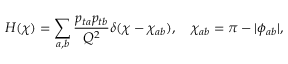Convert formula to latex. <formula><loc_0><loc_0><loc_500><loc_500>H ( \chi ) = \sum _ { a , b } \frac { p _ { t a } p _ { t b } } { Q ^ { 2 } } \delta ( \chi - \chi _ { a b } ) , \quad \chi _ { a b } = \pi - | \phi _ { a b } | ,</formula> 